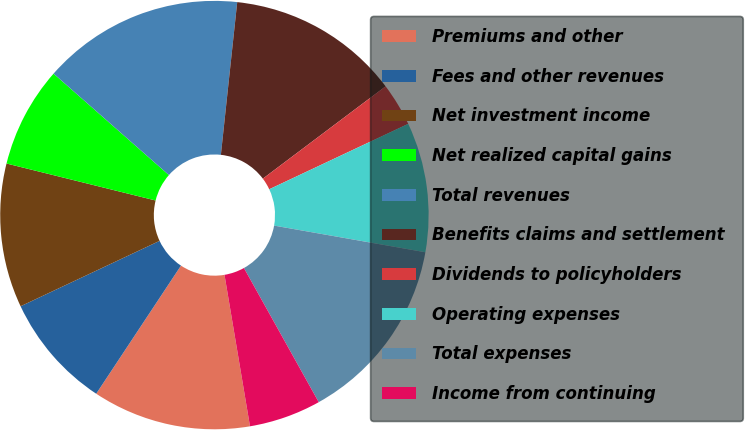Convert chart. <chart><loc_0><loc_0><loc_500><loc_500><pie_chart><fcel>Premiums and other<fcel>Fees and other revenues<fcel>Net investment income<fcel>Net realized capital gains<fcel>Total revenues<fcel>Benefits claims and settlement<fcel>Dividends to policyholders<fcel>Operating expenses<fcel>Total expenses<fcel>Income from continuing<nl><fcel>11.96%<fcel>8.7%<fcel>10.87%<fcel>7.61%<fcel>15.22%<fcel>13.04%<fcel>3.26%<fcel>9.78%<fcel>14.13%<fcel>5.44%<nl></chart> 